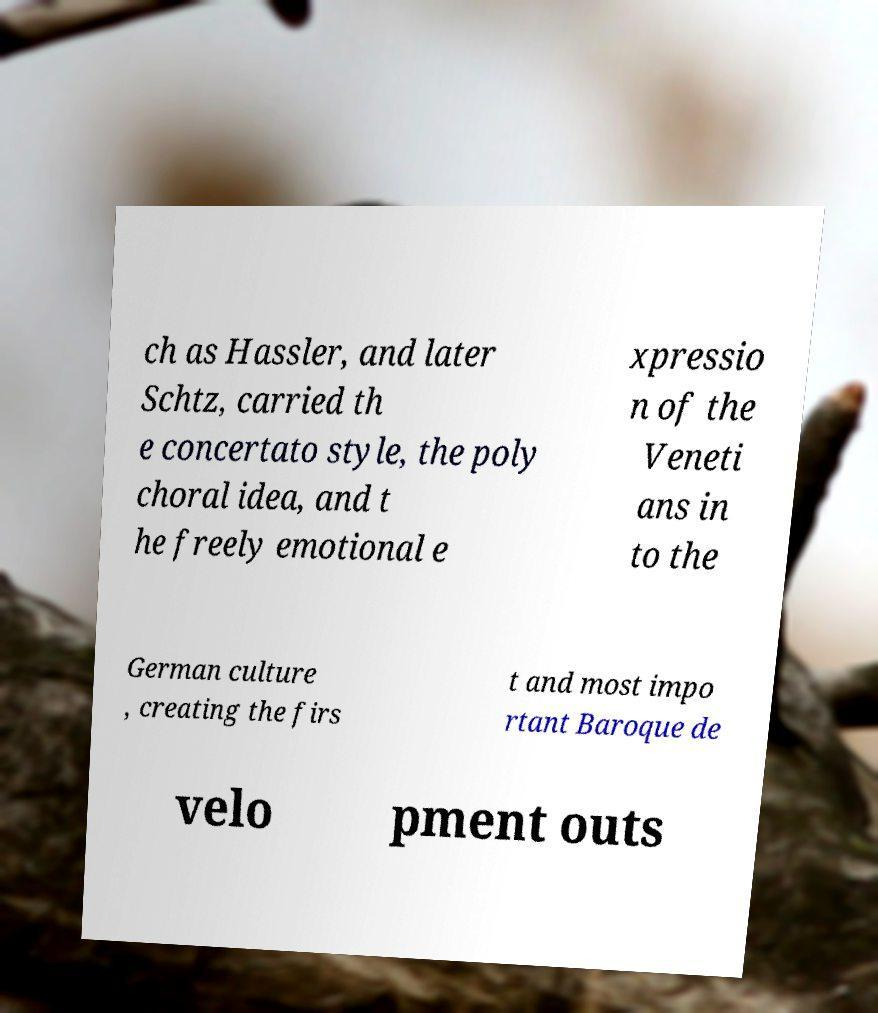For documentation purposes, I need the text within this image transcribed. Could you provide that? ch as Hassler, and later Schtz, carried th e concertato style, the poly choral idea, and t he freely emotional e xpressio n of the Veneti ans in to the German culture , creating the firs t and most impo rtant Baroque de velo pment outs 